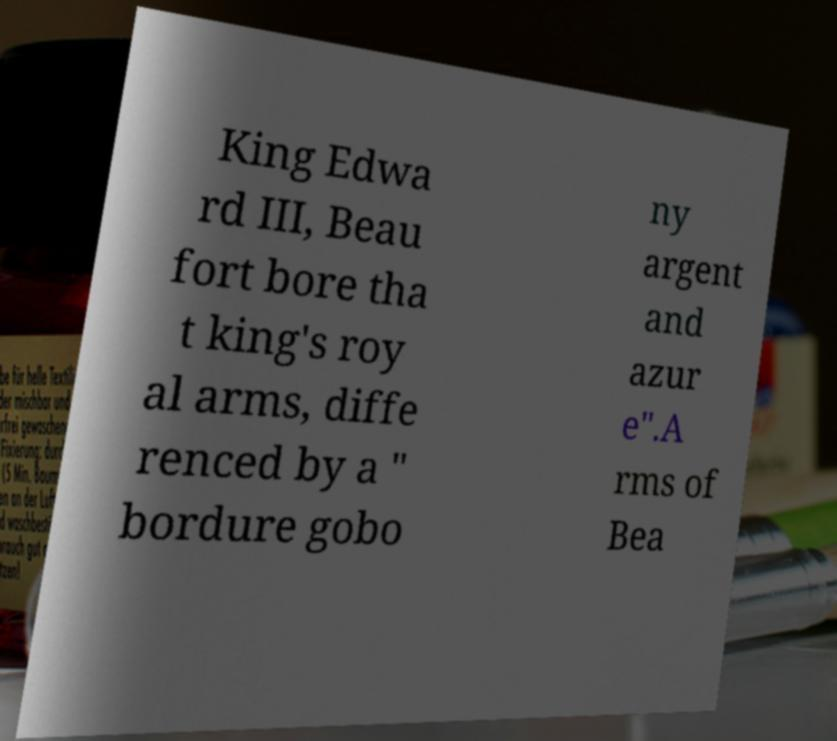Please identify and transcribe the text found in this image. King Edwa rd III, Beau fort bore tha t king's roy al arms, diffe renced by a " bordure gobo ny argent and azur e".A rms of Bea 